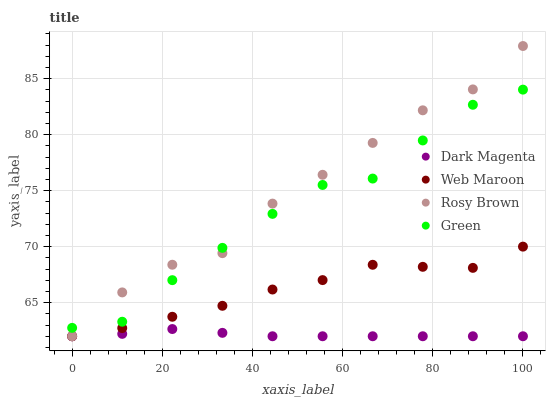Does Dark Magenta have the minimum area under the curve?
Answer yes or no. Yes. Does Rosy Brown have the maximum area under the curve?
Answer yes or no. Yes. Does Web Maroon have the minimum area under the curve?
Answer yes or no. No. Does Web Maroon have the maximum area under the curve?
Answer yes or no. No. Is Dark Magenta the smoothest?
Answer yes or no. Yes. Is Rosy Brown the roughest?
Answer yes or no. Yes. Is Web Maroon the smoothest?
Answer yes or no. No. Is Web Maroon the roughest?
Answer yes or no. No. Does Rosy Brown have the lowest value?
Answer yes or no. Yes. Does Rosy Brown have the highest value?
Answer yes or no. Yes. Does Web Maroon have the highest value?
Answer yes or no. No. Is Dark Magenta less than Green?
Answer yes or no. Yes. Is Green greater than Dark Magenta?
Answer yes or no. Yes. Does Green intersect Rosy Brown?
Answer yes or no. Yes. Is Green less than Rosy Brown?
Answer yes or no. No. Is Green greater than Rosy Brown?
Answer yes or no. No. Does Dark Magenta intersect Green?
Answer yes or no. No. 